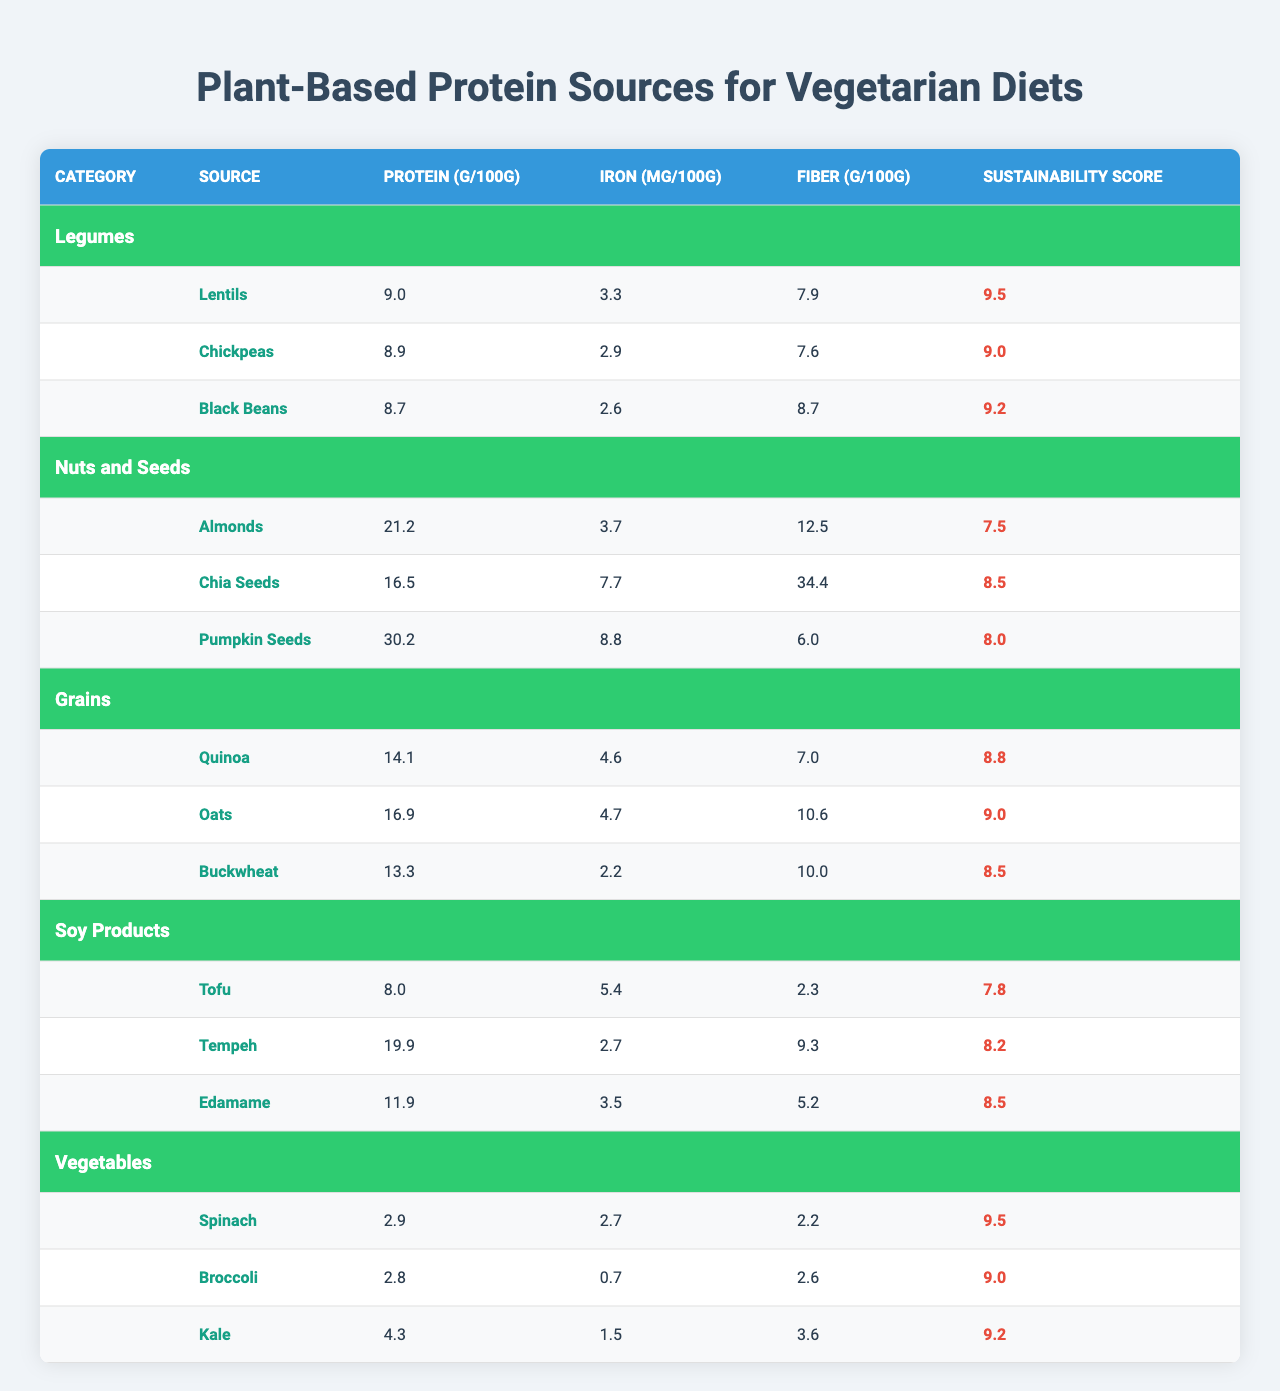What is the highest protein content among the plant-based sources listed? The table shows the protein content per 100 grams for each source. The highest value is found in Pumpkin Seeds, which has 30.2 g of protein per 100g.
Answer: 30.2 g Which plant-based protein source has the highest sustainability score? The table lists the sustainability scores for each source, with Lentils and Spinach both scoring 9.5, which is the highest.
Answer: Lentils, Spinach What is the average protein content of Legumes? The protein values for Legumes are 9.0 g (Lentils), 8.9 g (Chickpeas), and 8.7 g (Black Beans). To find the average: (9.0 + 8.9 + 8.7) / 3 = 8.8667, which rounds to approximately 8.87 g.
Answer: 8.87 g Is Tofu higher in protein content than Chickpeas? Tofu has 8.0 g of protein per 100g while Chickpeas have 8.9 g. Since 8.0 g is less than 8.9 g, Tofu is not higher in protein than Chickpeas.
Answer: No Which category has the highest average fiber content? To find this, calculate the average fiber for each category: Legumes (7.9 + 7.6 + 8.7) / 3 = 8.33 g, Nuts and Seeds (12.5 + 34.4 + 6.0) / 3 = 17.67 g, Grains (7.0 + 10.6 + 10.0) / 3 = 9.2 g, Soy Products (2.3 + 9.3 + 5.2) / 3 = 5.6 g, and Vegetables (2.2 + 2.6 + 3.6) / 3 = 2.8 g. The highest average fiber content is from Nuts and Seeds at 17.67 g.
Answer: Nuts and Seeds What is the iron content of Black Beans? The table indicates that Black Beans contain 2.6 mg of iron per 100 grams.
Answer: 2.6 mg Are Chia Seeds more sustainable than Almonds? Chia Seeds have a sustainability score of 8.5, while Almonds score 7.5, indicating that Chia Seeds are indeed more sustainable.
Answer: Yes Which plant-based protein source has the least iron content? The table shows the iron content for all sources. Broccoli has the least at 0.7 mg of iron per 100g.
Answer: Broccoli What is the total protein content of all sources in the Grains category? The protein values for Grains are 14.1 g (Quinoa), 16.9 g (Oats), and 13.3 g (Buckwheat). The total is: 14.1 + 16.9 + 13.3 = 44.3 g.
Answer: 44.3 g 